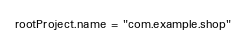<code> <loc_0><loc_0><loc_500><loc_500><_Kotlin_>rootProject.name = "com.example.shop"</code> 